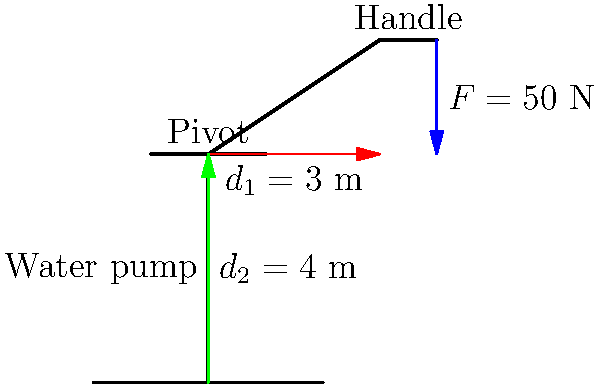A water pump is operated using a simple lever mechanism. The handle of the pump is 3 meters long, and the distance from the pivot to the pump shaft is 4 meters. If a force of 50 N is applied at the end of the handle, what is the force exerted on the pump shaft? To solve this problem, we'll use the principle of moments for a lever system:

1) The lever principle states that $F_1 \cdot d_1 = F_2 \cdot d_2$, where:
   $F_1$ is the input force (given)
   $d_1$ is the distance from the pivot to the input force (handle length)
   $F_2$ is the output force (what we're solving for)
   $d_2$ is the distance from the pivot to the output force (pump shaft length)

2) We know:
   $F_1 = 50$ N
   $d_1 = 3$ m
   $d_2 = 4$ m

3) Substituting these values into the equation:
   $50 \text{ N} \cdot 3 \text{ m} = F_2 \cdot 4 \text{ m}$

4) Simplify the left side:
   $150 \text{ N·m} = F_2 \cdot 4 \text{ m}$

5) Solve for $F_2$:
   $F_2 = \frac{150 \text{ N·m}}{4 \text{ m}} = 37.5 \text{ N}$

Therefore, the force exerted on the pump shaft is 37.5 N.
Answer: 37.5 N 